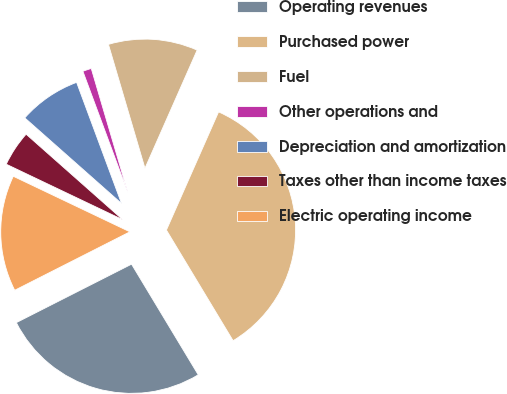<chart> <loc_0><loc_0><loc_500><loc_500><pie_chart><fcel>Operating revenues<fcel>Purchased power<fcel>Fuel<fcel>Other operations and<fcel>Depreciation and amortization<fcel>Taxes other than income taxes<fcel>Electric operating income<nl><fcel>26.16%<fcel>34.75%<fcel>11.18%<fcel>1.09%<fcel>7.82%<fcel>4.45%<fcel>14.55%<nl></chart> 